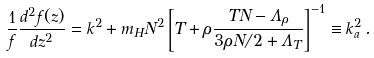Convert formula to latex. <formula><loc_0><loc_0><loc_500><loc_500>\frac { 1 } { f } \frac { d ^ { 2 } f ( z ) } { d z ^ { 2 } } = k ^ { 2 } + m _ { H } N ^ { 2 } \left [ T + \rho \frac { T N - \Lambda _ { \rho } } { 3 \rho N / 2 + \Lambda _ { T } } \right ] ^ { - 1 } \equiv k _ { a } ^ { 2 } \, .</formula> 